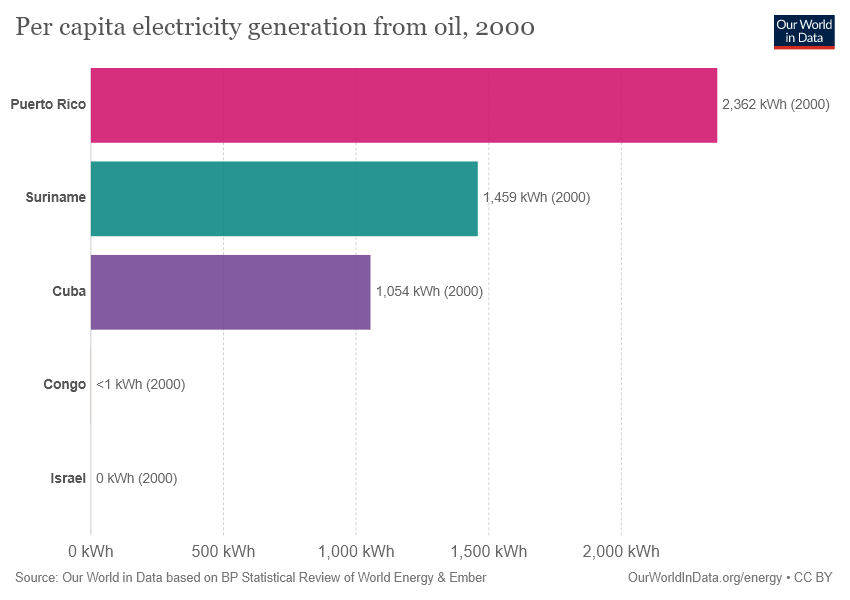Point out several critical features in this image. The average of the two largest bars is 1910.5. The second largest bar value in the graph is Suriname. 